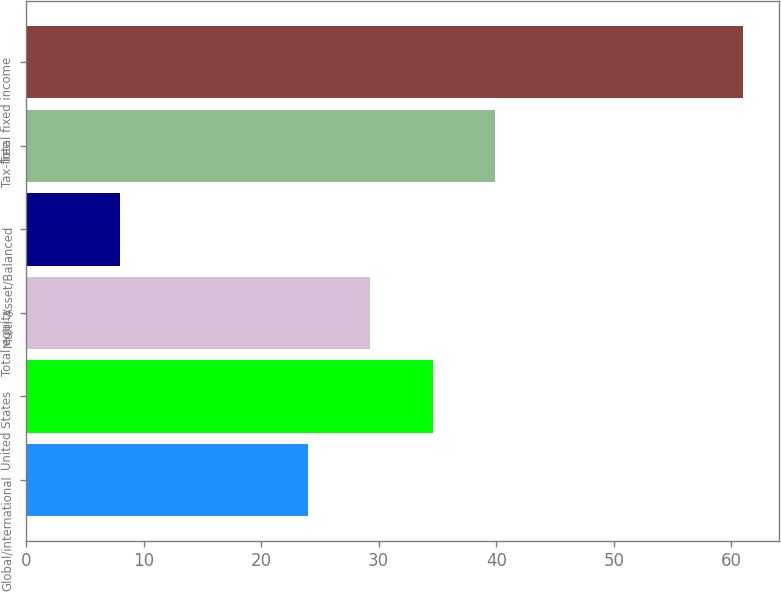<chart> <loc_0><loc_0><loc_500><loc_500><bar_chart><fcel>Global/international<fcel>United States<fcel>Total equity<fcel>Multi-Asset/Balanced<fcel>Tax-free<fcel>Total fixed income<nl><fcel>24<fcel>34.6<fcel>29.3<fcel>8<fcel>39.9<fcel>61<nl></chart> 